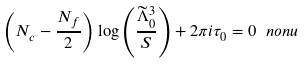<formula> <loc_0><loc_0><loc_500><loc_500>\left ( N _ { c } - \frac { N _ { f } } { 2 } \right ) \log \left ( \frac { \widetilde { \Lambda } _ { 0 } ^ { 3 } } { S } \right ) + 2 \pi i \tau _ { 0 } = 0 \ n o n u</formula> 